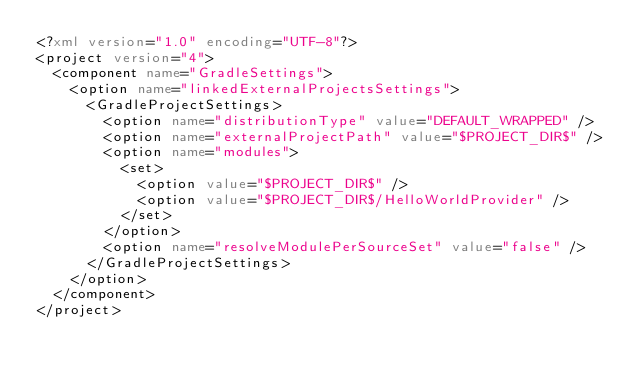<code> <loc_0><loc_0><loc_500><loc_500><_XML_><?xml version="1.0" encoding="UTF-8"?>
<project version="4">
  <component name="GradleSettings">
    <option name="linkedExternalProjectsSettings">
      <GradleProjectSettings>
        <option name="distributionType" value="DEFAULT_WRAPPED" />
        <option name="externalProjectPath" value="$PROJECT_DIR$" />
        <option name="modules">
          <set>
            <option value="$PROJECT_DIR$" />
            <option value="$PROJECT_DIR$/HelloWorldProvider" />
          </set>
        </option>
        <option name="resolveModulePerSourceSet" value="false" />
      </GradleProjectSettings>
    </option>
  </component>
</project></code> 